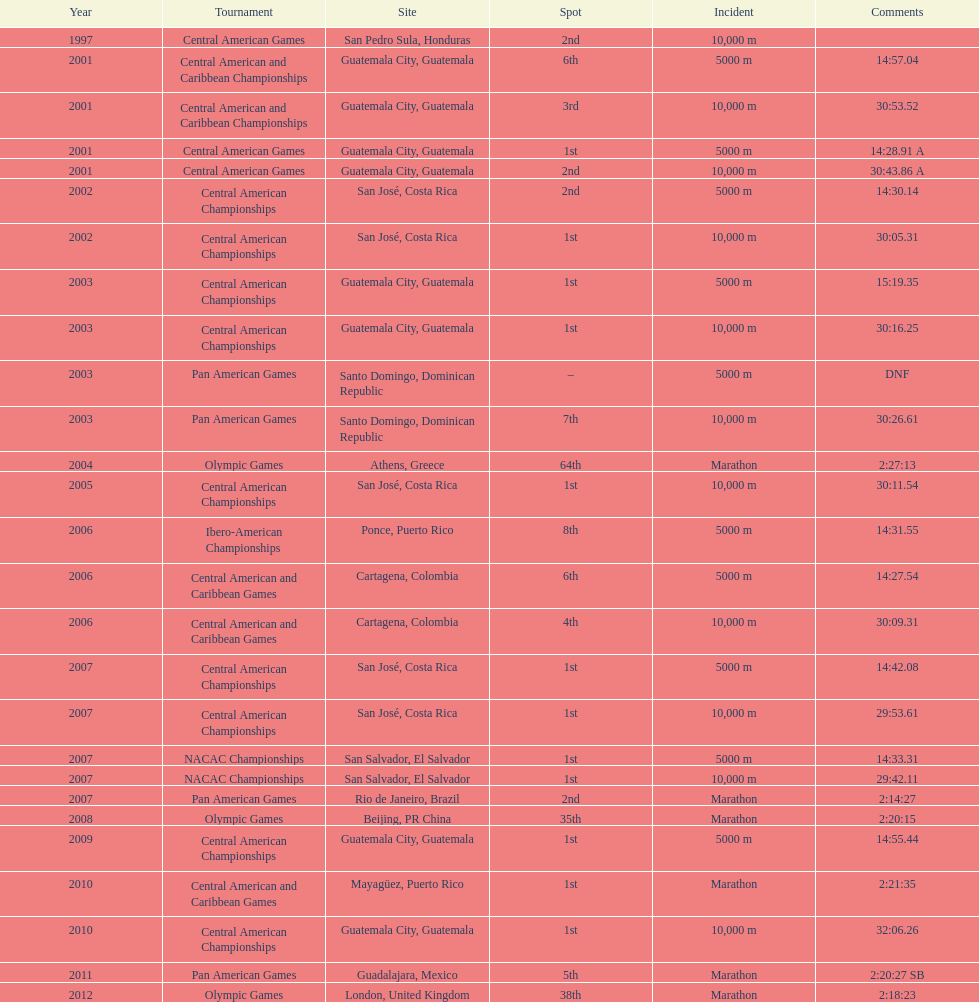How many times has the position of 1st been achieved? 12. 